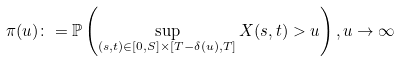Convert formula to latex. <formula><loc_0><loc_0><loc_500><loc_500>\pi ( u ) \colon = \mathbb { P } \left ( \sup _ { ( s , t ) \in [ 0 , S ] \times [ T - \delta ( u ) , T ] } X ( s , t ) > u \right ) , u \rightarrow \infty</formula> 